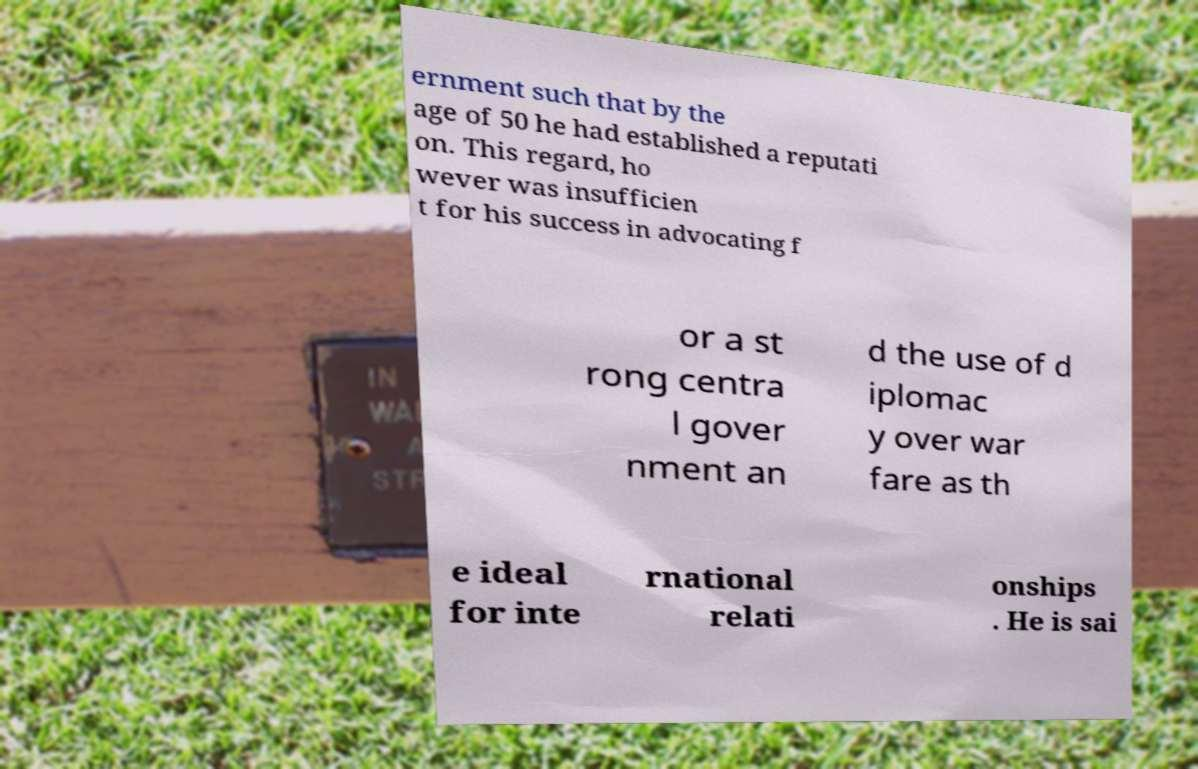Could you assist in decoding the text presented in this image and type it out clearly? ernment such that by the age of 50 he had established a reputati on. This regard, ho wever was insufficien t for his success in advocating f or a st rong centra l gover nment an d the use of d iplomac y over war fare as th e ideal for inte rnational relati onships . He is sai 